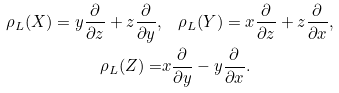Convert formula to latex. <formula><loc_0><loc_0><loc_500><loc_500>\rho _ { L } ( X ) = y \frac { \partial } { \partial z } + z \frac { \partial } { \partial y } , & \quad \rho _ { L } ( Y ) = x \frac { \partial } { \partial z } + z \frac { \partial } { \partial x } , \\ \rho _ { L } ( Z ) = & x \frac { \partial } { \partial y } - y \frac { \partial } { \partial x } .</formula> 